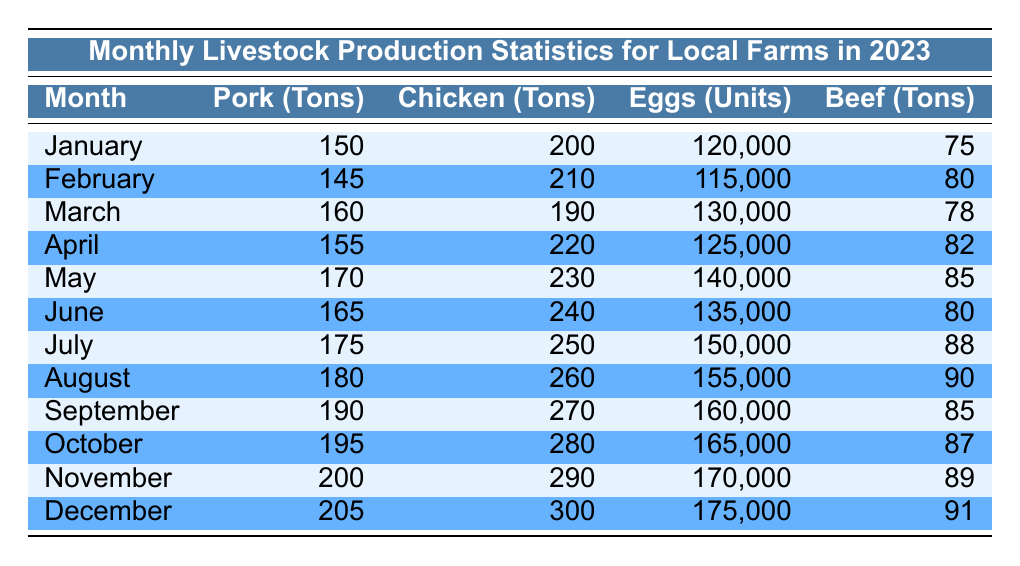What was the total pork production in March and April? The pork production in March is 160 tons, and in April it is 155 tons. Adding these together gives 160 + 155 = 315 tons.
Answer: 315 tons Which month had the highest chicken production? By examining the table, the highest chicken production value is in December, with 300 tons produced.
Answer: December Did the egg production increase every month throughout the year? Checking the egg production values month by month shows the following: 120000, 115000, 130000, 125000, 140000, 135000, 150000, 155000, 160000, 165000, 170000, 175000. The production decreased from January to February but then consistently increased for the rest of the year. Thus, it did not increase every month.
Answer: No What is the average beef production across the year? To find the average beef production, sum the total beef production values for each month: 75 + 80 + 78 + 82 + 85 + 80 + 88 + 90 + 85 + 87 + 89 + 91 = 1004. There are 12 months, so 1004 / 12 = 83.67 tons (rounded to two decimal places).
Answer: 83.67 tons Which month had a higher total livestock production, July or October? For July, total livestock production can be calculated as 175 tons (pork) + 250 tons (chicken) + 150000 units (eggs, converted to tons as approximately 150) + 88 tons (beef) = approximately 663 tons. For October, the total is 195 tons (pork) + 280 tons (chicken) + 165000 units (eggs, converted to tons as approximately 165) + 87 tons (beef) = approximately 727 tons. Comparing the two totals shows October had higher production.
Answer: October What was the difference in pork production between November and January? The pork production in November is 200 tons, while in January it is 150 tons. The difference is calculated as 200 - 150 = 50 tons.
Answer: 50 tons 